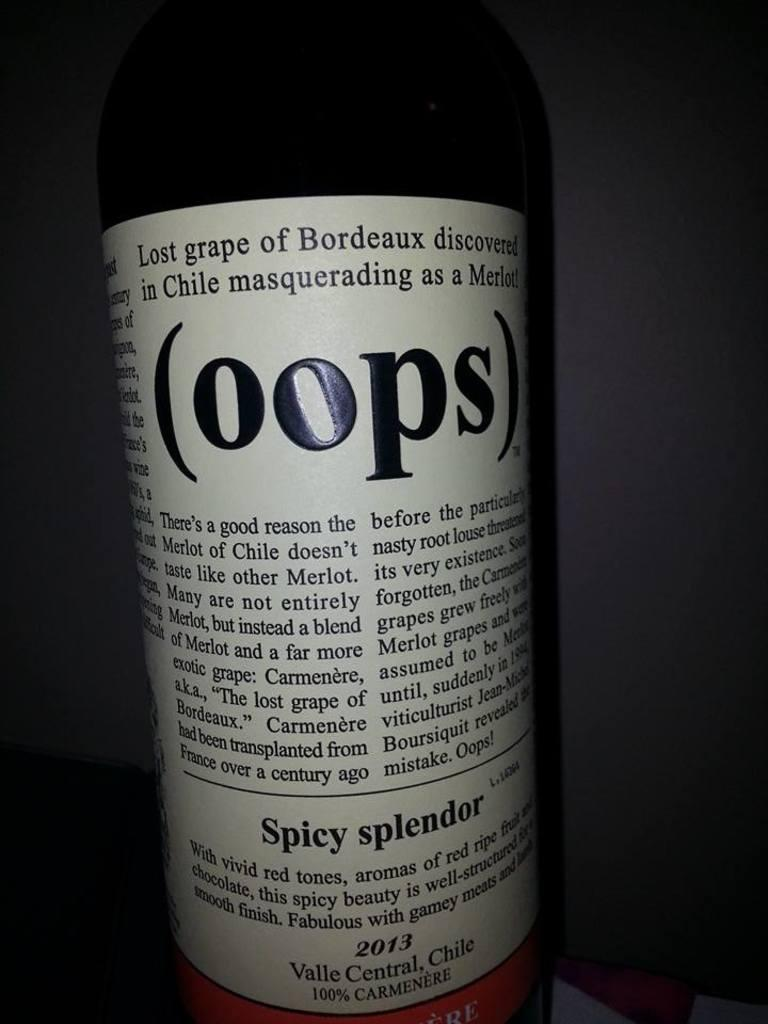<image>
Summarize the visual content of the image. the word oops that is on a bottle 